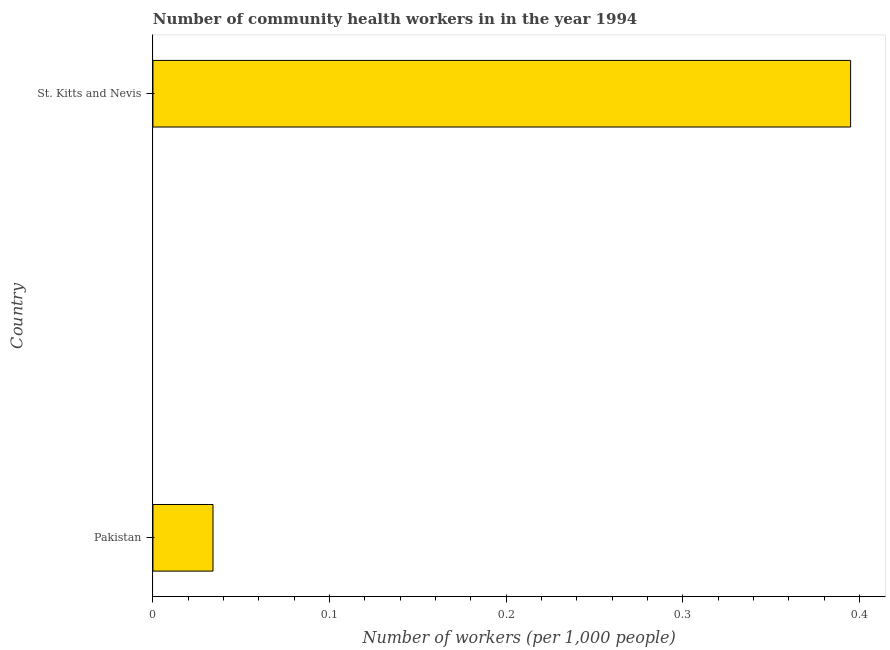Does the graph contain grids?
Your response must be concise. No. What is the title of the graph?
Offer a very short reply. Number of community health workers in in the year 1994. What is the label or title of the X-axis?
Your response must be concise. Number of workers (per 1,0 people). What is the label or title of the Y-axis?
Your response must be concise. Country. What is the number of community health workers in St. Kitts and Nevis?
Ensure brevity in your answer.  0.4. Across all countries, what is the maximum number of community health workers?
Your answer should be very brief. 0.4. Across all countries, what is the minimum number of community health workers?
Your answer should be compact. 0.03. In which country was the number of community health workers maximum?
Make the answer very short. St. Kitts and Nevis. In which country was the number of community health workers minimum?
Give a very brief answer. Pakistan. What is the sum of the number of community health workers?
Your answer should be very brief. 0.43. What is the difference between the number of community health workers in Pakistan and St. Kitts and Nevis?
Provide a short and direct response. -0.36. What is the average number of community health workers per country?
Give a very brief answer. 0.21. What is the median number of community health workers?
Ensure brevity in your answer.  0.21. What is the ratio of the number of community health workers in Pakistan to that in St. Kitts and Nevis?
Give a very brief answer. 0.09. How many countries are there in the graph?
Provide a short and direct response. 2. What is the Number of workers (per 1,000 people) in Pakistan?
Provide a short and direct response. 0.03. What is the Number of workers (per 1,000 people) of St. Kitts and Nevis?
Offer a very short reply. 0.4. What is the difference between the Number of workers (per 1,000 people) in Pakistan and St. Kitts and Nevis?
Your answer should be very brief. -0.36. What is the ratio of the Number of workers (per 1,000 people) in Pakistan to that in St. Kitts and Nevis?
Make the answer very short. 0.09. 